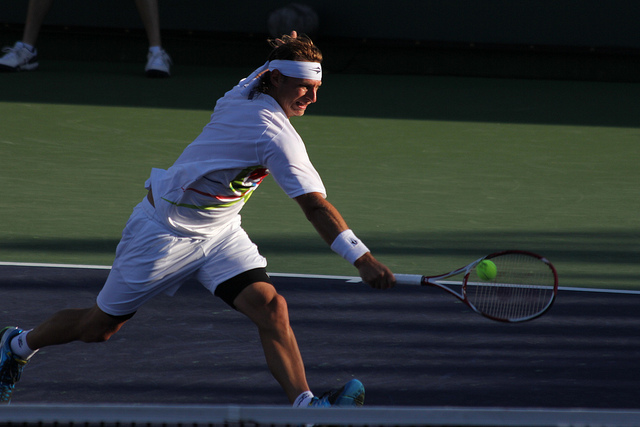<image>What team is this player on? I am not sure which team the player is on. It might be the white team, tennis team, or it could be that the player is solo. What team is this player on? I don't know what team this player is on. It can be 'white team', 'rock', 'tennis team', 'his own', 'usa', 'tennis', or 'solo'. 